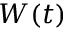Convert formula to latex. <formula><loc_0><loc_0><loc_500><loc_500>W ( t )</formula> 